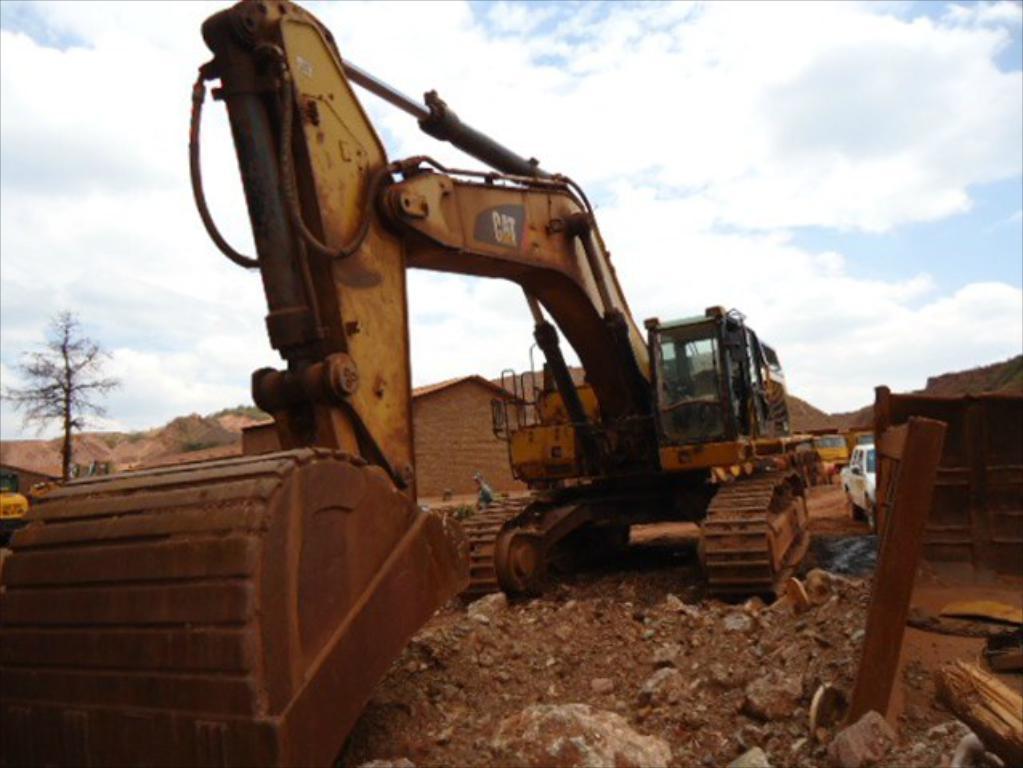Could you give a brief overview of what you see in this image? In the image we can see an excavator. Behind the excavator there are some vehicles and buildings and trees. At the top of the image there are some clouds and sky. 